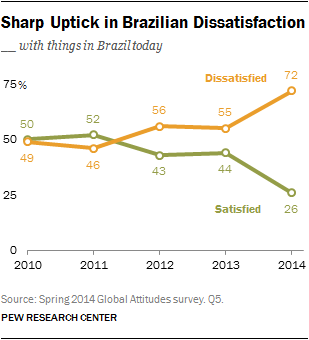Indicate a few pertinent items in this graphic. In 2013, the value of the green line was 44. In 2014, the difference between those who were satisfied and those who were dissatisfied with the current state of the country reached its greatest level. 